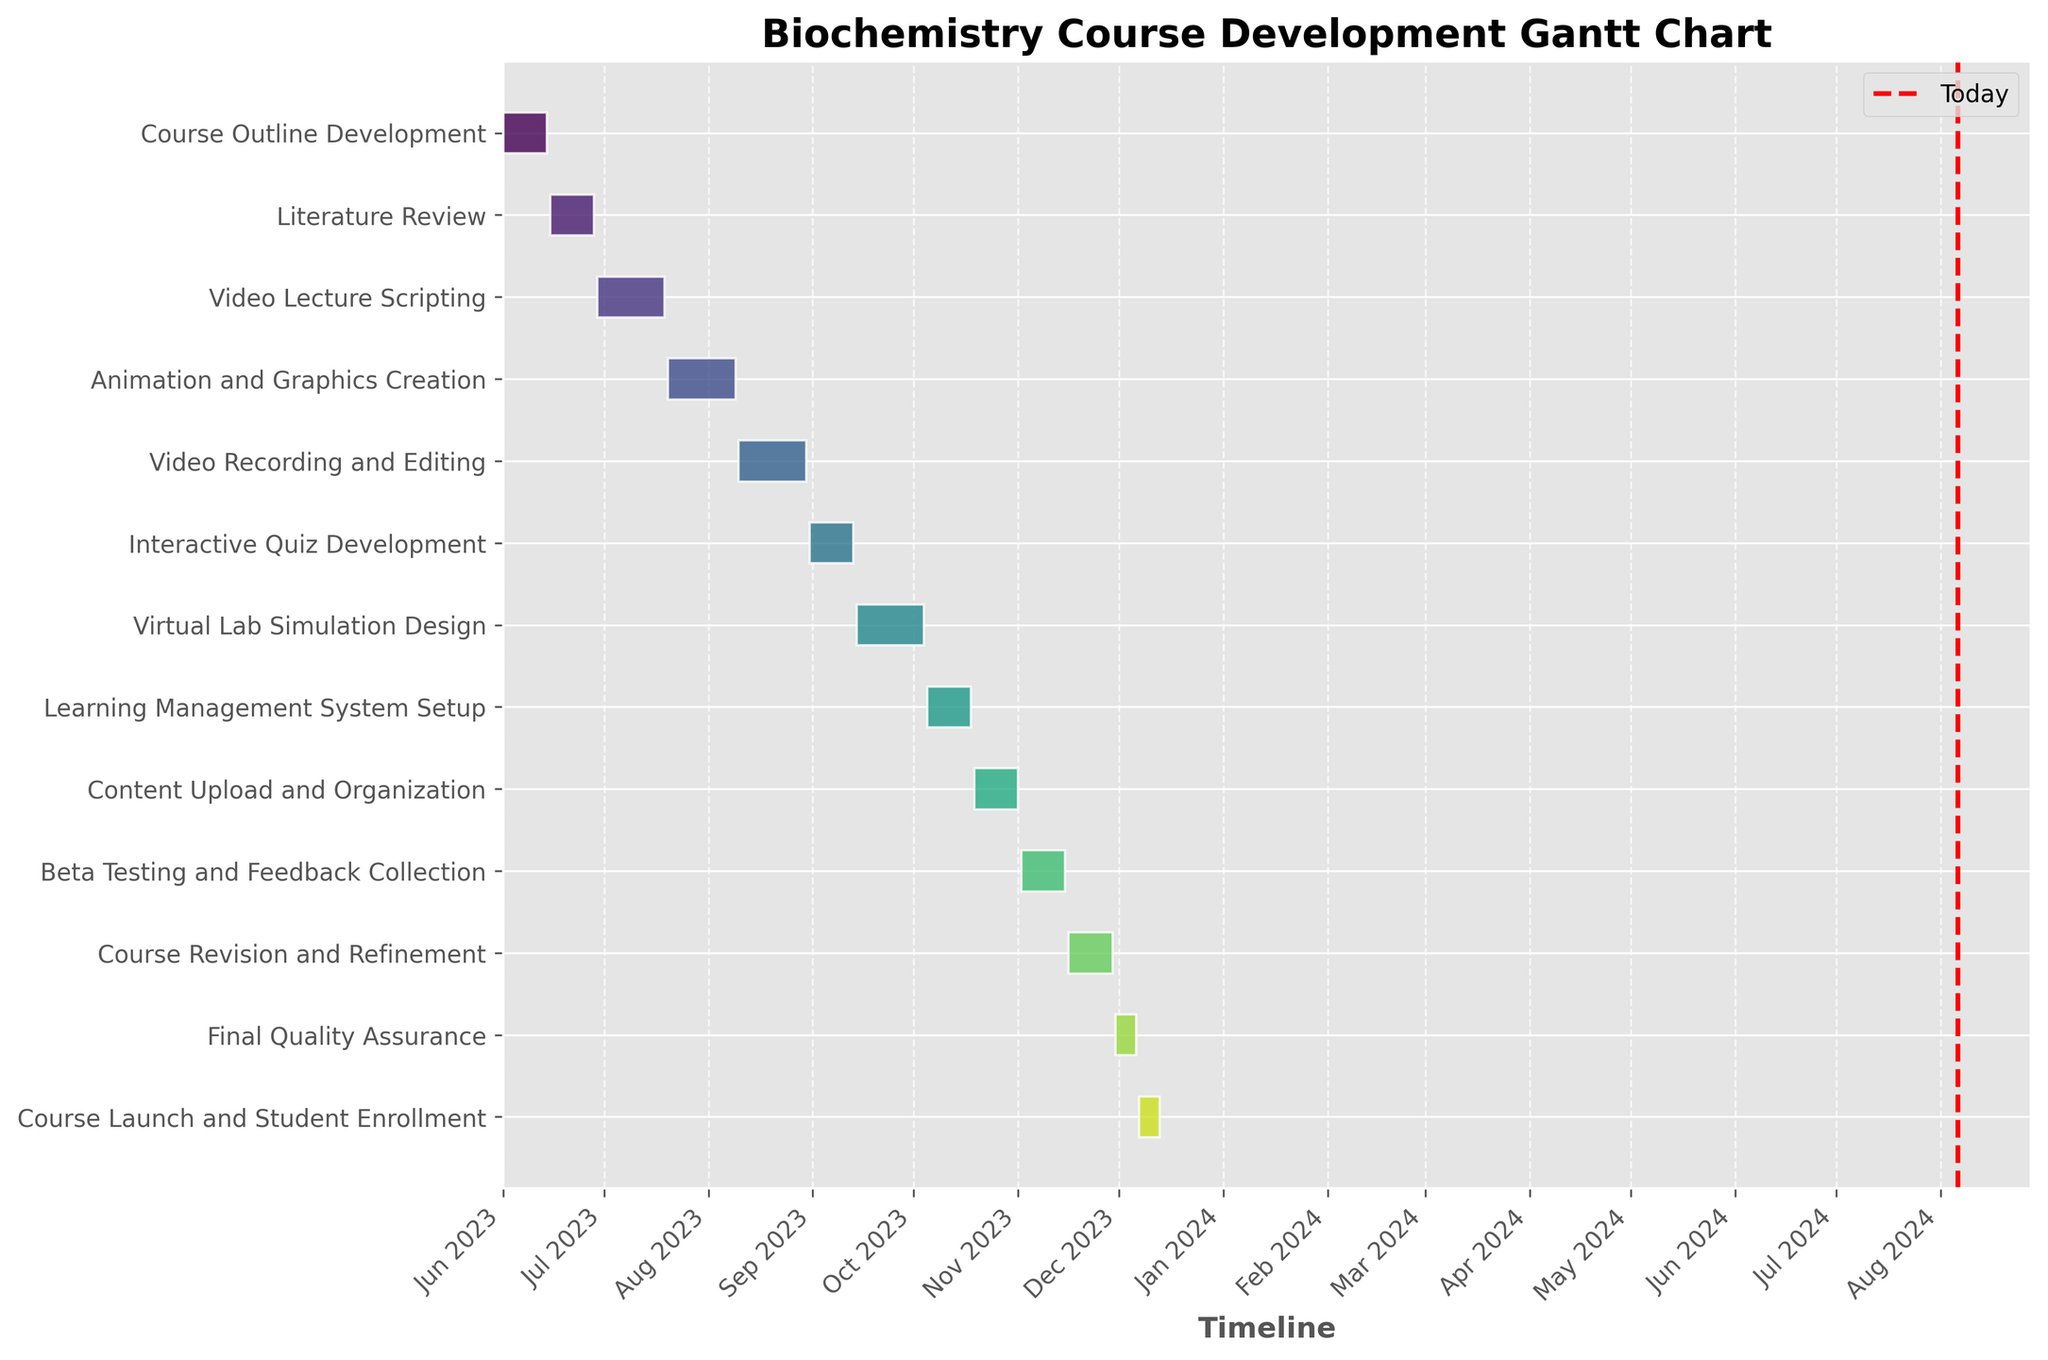What is the title of the Gantt Chart? The title of the Gantt Chart can typically be found at the top of the figure. It provides a summary of the chart's content and purpose. In this case, look above the bars to identify the title.
Answer: Biochemistry Course Development Gantt Chart How many tasks are scheduled for the development of the online biochemistry course? To determine the number of tasks, count the number of horizontal bars or rows in the Gantt Chart, as each bar represents a task.
Answer: 13 Which task is scheduled to begin first and which task is scheduled to end last? The task that begins first will have the leftmost starting point on the Gantt Chart, while the task that ends last will have the rightmost ending point.
Answer: Course Outline Development (first), Course Launch and Student Enrollment (last) Which task has the longest duration, and how long is it? To identify the task with the longest duration, compare the lengths of the horizontal bars. The longest bar represents the task with the longest duration. Look at the chart to find the task and check the scale to determine the duration in days.
Answer: Video Lecture Scripting and three other tasks (21 days) How many tasks are scheduled to be completed in August 2023? To answer this, identify the bars that either start or end in August 2023. Count the number of these bars.
Answer: 2 When does the "Learning Management System Setup" task start and end? Locate the "Learning Management System Setup" task on the y-axis, then follow the corresponding bar horizontally to read its start and end dates from the x-axis.
Answer: October 5, 2023 (start), October 18, 2023 (end) How many days after the "Interactive Quiz Development" task ends does the "Beta Testing and Feedback Collection" task start? First, determine the end date of "Interactive Quiz Development" and the start date of "Beta Testing and Feedback Collection" by reading the Gantt Chart. Then, calculate the days between these two dates.
Answer: 50 days Compare the total duration of all tasks. What is the combined duration in days? Add up the individual durations of all tasks listed in the Gantt Chart to get the total duration.
Answer: 205 days Which month has the highest number of tasks starting? To find this, count the number of bars that start within each month. Identify the month with the highest count.
Answer: June How does the timeline of "Course Revision and Refinement" compare to "Final Quality Assurance"? Locate each task on the Gantt Chart and compare their start and end dates. This determines which task starts earlier, which ends later, and if there is any overlap.
Answer: "Course Revision and Refinement" starts earlier and ends later 